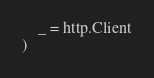<code> <loc_0><loc_0><loc_500><loc_500><_Go_>	_ = http.Client
)
</code> 